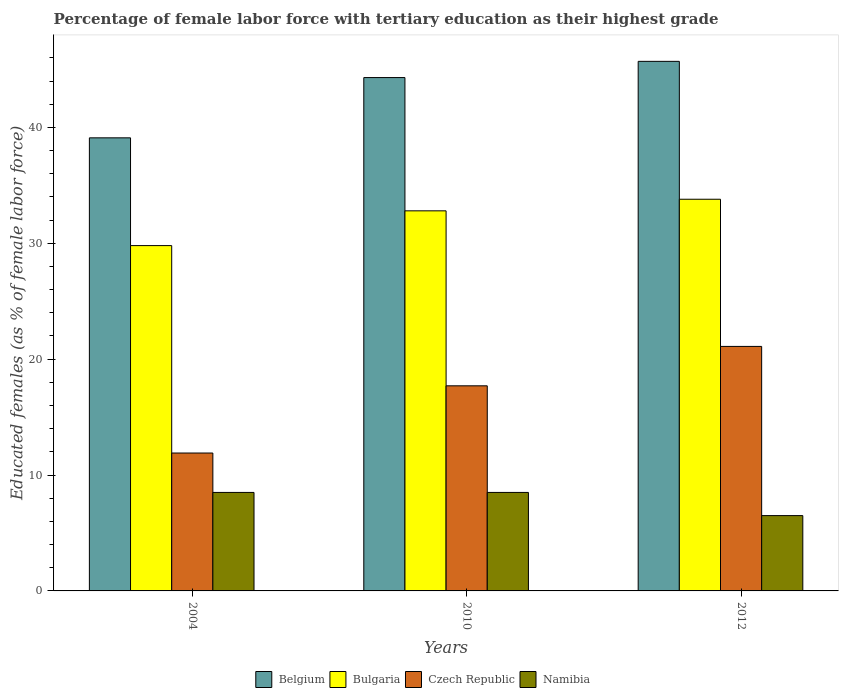How many different coloured bars are there?
Offer a terse response. 4. How many groups of bars are there?
Ensure brevity in your answer.  3. How many bars are there on the 2nd tick from the right?
Your answer should be compact. 4. What is the label of the 2nd group of bars from the left?
Offer a very short reply. 2010. In how many cases, is the number of bars for a given year not equal to the number of legend labels?
Your answer should be compact. 0. What is the percentage of female labor force with tertiary education in Namibia in 2010?
Give a very brief answer. 8.5. Across all years, what is the maximum percentage of female labor force with tertiary education in Namibia?
Keep it short and to the point. 8.5. Across all years, what is the minimum percentage of female labor force with tertiary education in Belgium?
Offer a terse response. 39.1. In which year was the percentage of female labor force with tertiary education in Czech Republic maximum?
Provide a succinct answer. 2012. What is the total percentage of female labor force with tertiary education in Bulgaria in the graph?
Give a very brief answer. 96.4. What is the difference between the percentage of female labor force with tertiary education in Belgium in 2004 and that in 2012?
Your answer should be very brief. -6.6. What is the difference between the percentage of female labor force with tertiary education in Bulgaria in 2012 and the percentage of female labor force with tertiary education in Czech Republic in 2004?
Give a very brief answer. 21.9. What is the average percentage of female labor force with tertiary education in Namibia per year?
Make the answer very short. 7.83. In the year 2004, what is the difference between the percentage of female labor force with tertiary education in Namibia and percentage of female labor force with tertiary education in Belgium?
Keep it short and to the point. -30.6. What is the ratio of the percentage of female labor force with tertiary education in Bulgaria in 2004 to that in 2012?
Make the answer very short. 0.88. Is the percentage of female labor force with tertiary education in Namibia in 2004 less than that in 2010?
Your answer should be compact. No. Is the difference between the percentage of female labor force with tertiary education in Namibia in 2004 and 2012 greater than the difference between the percentage of female labor force with tertiary education in Belgium in 2004 and 2012?
Ensure brevity in your answer.  Yes. What is the difference between the highest and the second highest percentage of female labor force with tertiary education in Namibia?
Provide a succinct answer. 0. What is the difference between the highest and the lowest percentage of female labor force with tertiary education in Czech Republic?
Offer a terse response. 9.2. In how many years, is the percentage of female labor force with tertiary education in Bulgaria greater than the average percentage of female labor force with tertiary education in Bulgaria taken over all years?
Make the answer very short. 2. What does the 4th bar from the left in 2004 represents?
Your answer should be very brief. Namibia. Is it the case that in every year, the sum of the percentage of female labor force with tertiary education in Czech Republic and percentage of female labor force with tertiary education in Namibia is greater than the percentage of female labor force with tertiary education in Belgium?
Your response must be concise. No. How many bars are there?
Make the answer very short. 12. Does the graph contain any zero values?
Offer a terse response. No. Does the graph contain grids?
Ensure brevity in your answer.  No. How many legend labels are there?
Your response must be concise. 4. What is the title of the graph?
Offer a terse response. Percentage of female labor force with tertiary education as their highest grade. Does "Philippines" appear as one of the legend labels in the graph?
Provide a succinct answer. No. What is the label or title of the X-axis?
Make the answer very short. Years. What is the label or title of the Y-axis?
Your answer should be very brief. Educated females (as % of female labor force). What is the Educated females (as % of female labor force) in Belgium in 2004?
Ensure brevity in your answer.  39.1. What is the Educated females (as % of female labor force) of Bulgaria in 2004?
Keep it short and to the point. 29.8. What is the Educated females (as % of female labor force) of Czech Republic in 2004?
Your answer should be very brief. 11.9. What is the Educated females (as % of female labor force) in Belgium in 2010?
Offer a very short reply. 44.3. What is the Educated females (as % of female labor force) of Bulgaria in 2010?
Provide a short and direct response. 32.8. What is the Educated females (as % of female labor force) of Czech Republic in 2010?
Make the answer very short. 17.7. What is the Educated females (as % of female labor force) in Belgium in 2012?
Provide a succinct answer. 45.7. What is the Educated females (as % of female labor force) of Bulgaria in 2012?
Your response must be concise. 33.8. What is the Educated females (as % of female labor force) of Czech Republic in 2012?
Your answer should be very brief. 21.1. Across all years, what is the maximum Educated females (as % of female labor force) of Belgium?
Offer a very short reply. 45.7. Across all years, what is the maximum Educated females (as % of female labor force) of Bulgaria?
Offer a very short reply. 33.8. Across all years, what is the maximum Educated females (as % of female labor force) in Czech Republic?
Provide a succinct answer. 21.1. Across all years, what is the maximum Educated females (as % of female labor force) in Namibia?
Offer a terse response. 8.5. Across all years, what is the minimum Educated females (as % of female labor force) in Belgium?
Your response must be concise. 39.1. Across all years, what is the minimum Educated females (as % of female labor force) in Bulgaria?
Offer a very short reply. 29.8. Across all years, what is the minimum Educated females (as % of female labor force) in Czech Republic?
Ensure brevity in your answer.  11.9. Across all years, what is the minimum Educated females (as % of female labor force) in Namibia?
Give a very brief answer. 6.5. What is the total Educated females (as % of female labor force) of Belgium in the graph?
Give a very brief answer. 129.1. What is the total Educated females (as % of female labor force) in Bulgaria in the graph?
Offer a terse response. 96.4. What is the total Educated females (as % of female labor force) of Czech Republic in the graph?
Ensure brevity in your answer.  50.7. What is the total Educated females (as % of female labor force) of Namibia in the graph?
Provide a short and direct response. 23.5. What is the difference between the Educated females (as % of female labor force) in Belgium in 2004 and that in 2010?
Ensure brevity in your answer.  -5.2. What is the difference between the Educated females (as % of female labor force) in Czech Republic in 2004 and that in 2010?
Provide a succinct answer. -5.8. What is the difference between the Educated females (as % of female labor force) in Namibia in 2010 and that in 2012?
Provide a succinct answer. 2. What is the difference between the Educated females (as % of female labor force) of Belgium in 2004 and the Educated females (as % of female labor force) of Czech Republic in 2010?
Provide a succinct answer. 21.4. What is the difference between the Educated females (as % of female labor force) in Belgium in 2004 and the Educated females (as % of female labor force) in Namibia in 2010?
Make the answer very short. 30.6. What is the difference between the Educated females (as % of female labor force) of Bulgaria in 2004 and the Educated females (as % of female labor force) of Czech Republic in 2010?
Offer a terse response. 12.1. What is the difference between the Educated females (as % of female labor force) of Bulgaria in 2004 and the Educated females (as % of female labor force) of Namibia in 2010?
Ensure brevity in your answer.  21.3. What is the difference between the Educated females (as % of female labor force) of Belgium in 2004 and the Educated females (as % of female labor force) of Bulgaria in 2012?
Your response must be concise. 5.3. What is the difference between the Educated females (as % of female labor force) of Belgium in 2004 and the Educated females (as % of female labor force) of Czech Republic in 2012?
Give a very brief answer. 18. What is the difference between the Educated females (as % of female labor force) in Belgium in 2004 and the Educated females (as % of female labor force) in Namibia in 2012?
Ensure brevity in your answer.  32.6. What is the difference between the Educated females (as % of female labor force) in Bulgaria in 2004 and the Educated females (as % of female labor force) in Czech Republic in 2012?
Give a very brief answer. 8.7. What is the difference between the Educated females (as % of female labor force) of Bulgaria in 2004 and the Educated females (as % of female labor force) of Namibia in 2012?
Make the answer very short. 23.3. What is the difference between the Educated females (as % of female labor force) of Czech Republic in 2004 and the Educated females (as % of female labor force) of Namibia in 2012?
Offer a terse response. 5.4. What is the difference between the Educated females (as % of female labor force) of Belgium in 2010 and the Educated females (as % of female labor force) of Czech Republic in 2012?
Your answer should be very brief. 23.2. What is the difference between the Educated females (as % of female labor force) of Belgium in 2010 and the Educated females (as % of female labor force) of Namibia in 2012?
Offer a terse response. 37.8. What is the difference between the Educated females (as % of female labor force) in Bulgaria in 2010 and the Educated females (as % of female labor force) in Czech Republic in 2012?
Provide a succinct answer. 11.7. What is the difference between the Educated females (as % of female labor force) in Bulgaria in 2010 and the Educated females (as % of female labor force) in Namibia in 2012?
Offer a terse response. 26.3. What is the average Educated females (as % of female labor force) in Belgium per year?
Your answer should be very brief. 43.03. What is the average Educated females (as % of female labor force) of Bulgaria per year?
Offer a terse response. 32.13. What is the average Educated females (as % of female labor force) in Czech Republic per year?
Your answer should be compact. 16.9. What is the average Educated females (as % of female labor force) of Namibia per year?
Ensure brevity in your answer.  7.83. In the year 2004, what is the difference between the Educated females (as % of female labor force) in Belgium and Educated females (as % of female labor force) in Bulgaria?
Provide a succinct answer. 9.3. In the year 2004, what is the difference between the Educated females (as % of female labor force) in Belgium and Educated females (as % of female labor force) in Czech Republic?
Offer a terse response. 27.2. In the year 2004, what is the difference between the Educated females (as % of female labor force) in Belgium and Educated females (as % of female labor force) in Namibia?
Ensure brevity in your answer.  30.6. In the year 2004, what is the difference between the Educated females (as % of female labor force) in Bulgaria and Educated females (as % of female labor force) in Namibia?
Provide a succinct answer. 21.3. In the year 2004, what is the difference between the Educated females (as % of female labor force) in Czech Republic and Educated females (as % of female labor force) in Namibia?
Make the answer very short. 3.4. In the year 2010, what is the difference between the Educated females (as % of female labor force) in Belgium and Educated females (as % of female labor force) in Czech Republic?
Your answer should be very brief. 26.6. In the year 2010, what is the difference between the Educated females (as % of female labor force) of Belgium and Educated females (as % of female labor force) of Namibia?
Give a very brief answer. 35.8. In the year 2010, what is the difference between the Educated females (as % of female labor force) of Bulgaria and Educated females (as % of female labor force) of Czech Republic?
Keep it short and to the point. 15.1. In the year 2010, what is the difference between the Educated females (as % of female labor force) of Bulgaria and Educated females (as % of female labor force) of Namibia?
Offer a terse response. 24.3. In the year 2010, what is the difference between the Educated females (as % of female labor force) of Czech Republic and Educated females (as % of female labor force) of Namibia?
Make the answer very short. 9.2. In the year 2012, what is the difference between the Educated females (as % of female labor force) of Belgium and Educated females (as % of female labor force) of Bulgaria?
Offer a terse response. 11.9. In the year 2012, what is the difference between the Educated females (as % of female labor force) of Belgium and Educated females (as % of female labor force) of Czech Republic?
Your answer should be compact. 24.6. In the year 2012, what is the difference between the Educated females (as % of female labor force) of Belgium and Educated females (as % of female labor force) of Namibia?
Provide a succinct answer. 39.2. In the year 2012, what is the difference between the Educated females (as % of female labor force) of Bulgaria and Educated females (as % of female labor force) of Namibia?
Keep it short and to the point. 27.3. In the year 2012, what is the difference between the Educated females (as % of female labor force) in Czech Republic and Educated females (as % of female labor force) in Namibia?
Provide a short and direct response. 14.6. What is the ratio of the Educated females (as % of female labor force) of Belgium in 2004 to that in 2010?
Provide a short and direct response. 0.88. What is the ratio of the Educated females (as % of female labor force) in Bulgaria in 2004 to that in 2010?
Ensure brevity in your answer.  0.91. What is the ratio of the Educated females (as % of female labor force) of Czech Republic in 2004 to that in 2010?
Make the answer very short. 0.67. What is the ratio of the Educated females (as % of female labor force) of Belgium in 2004 to that in 2012?
Give a very brief answer. 0.86. What is the ratio of the Educated females (as % of female labor force) in Bulgaria in 2004 to that in 2012?
Ensure brevity in your answer.  0.88. What is the ratio of the Educated females (as % of female labor force) of Czech Republic in 2004 to that in 2012?
Keep it short and to the point. 0.56. What is the ratio of the Educated females (as % of female labor force) of Namibia in 2004 to that in 2012?
Give a very brief answer. 1.31. What is the ratio of the Educated females (as % of female labor force) of Belgium in 2010 to that in 2012?
Your answer should be very brief. 0.97. What is the ratio of the Educated females (as % of female labor force) of Bulgaria in 2010 to that in 2012?
Your answer should be very brief. 0.97. What is the ratio of the Educated females (as % of female labor force) of Czech Republic in 2010 to that in 2012?
Give a very brief answer. 0.84. What is the ratio of the Educated females (as % of female labor force) in Namibia in 2010 to that in 2012?
Ensure brevity in your answer.  1.31. What is the difference between the highest and the lowest Educated females (as % of female labor force) in Belgium?
Provide a succinct answer. 6.6. 